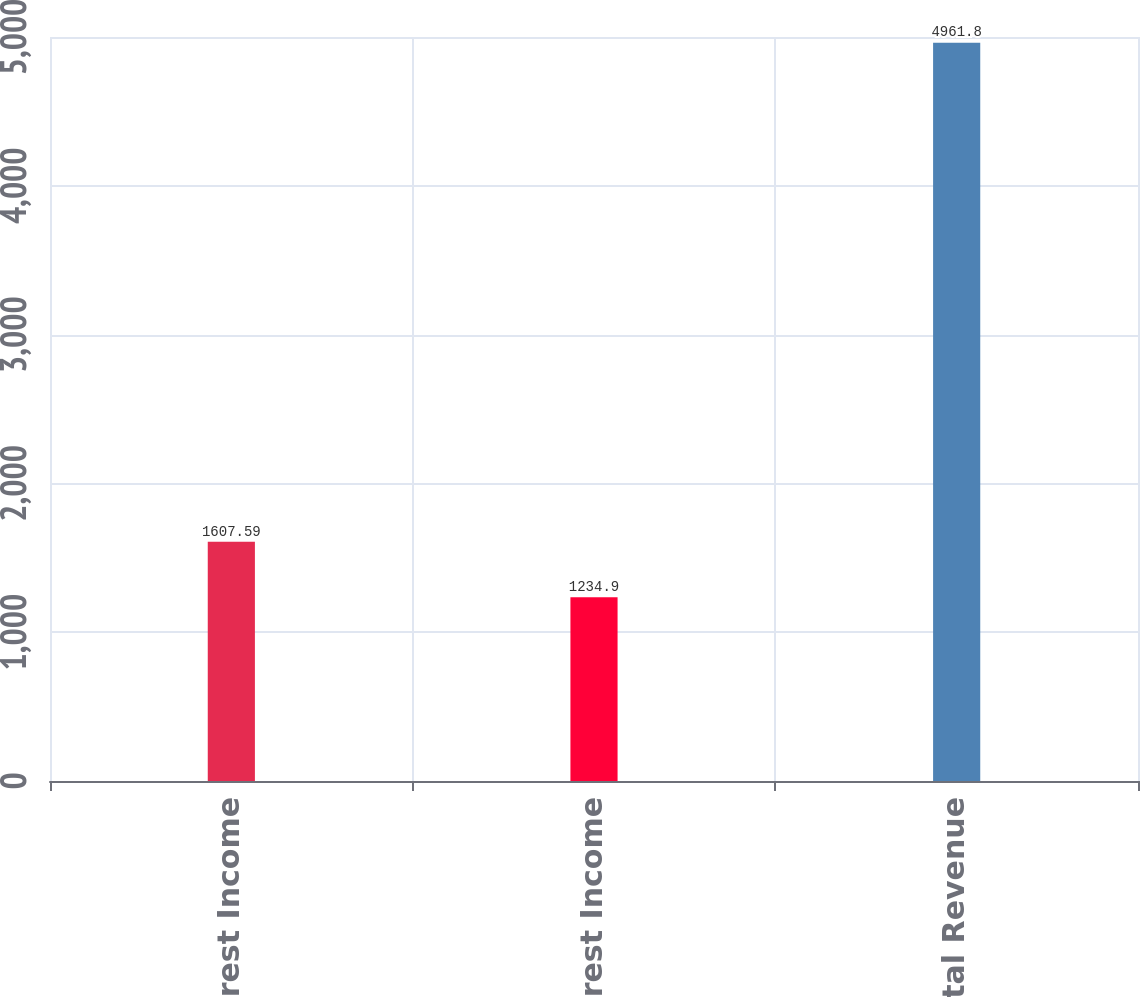Convert chart. <chart><loc_0><loc_0><loc_500><loc_500><bar_chart><fcel>Interest Income<fcel>Net Interest Income<fcel>Total Revenue<nl><fcel>1607.59<fcel>1234.9<fcel>4961.8<nl></chart> 